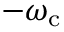Convert formula to latex. <formula><loc_0><loc_0><loc_500><loc_500>- \omega _ { c }</formula> 